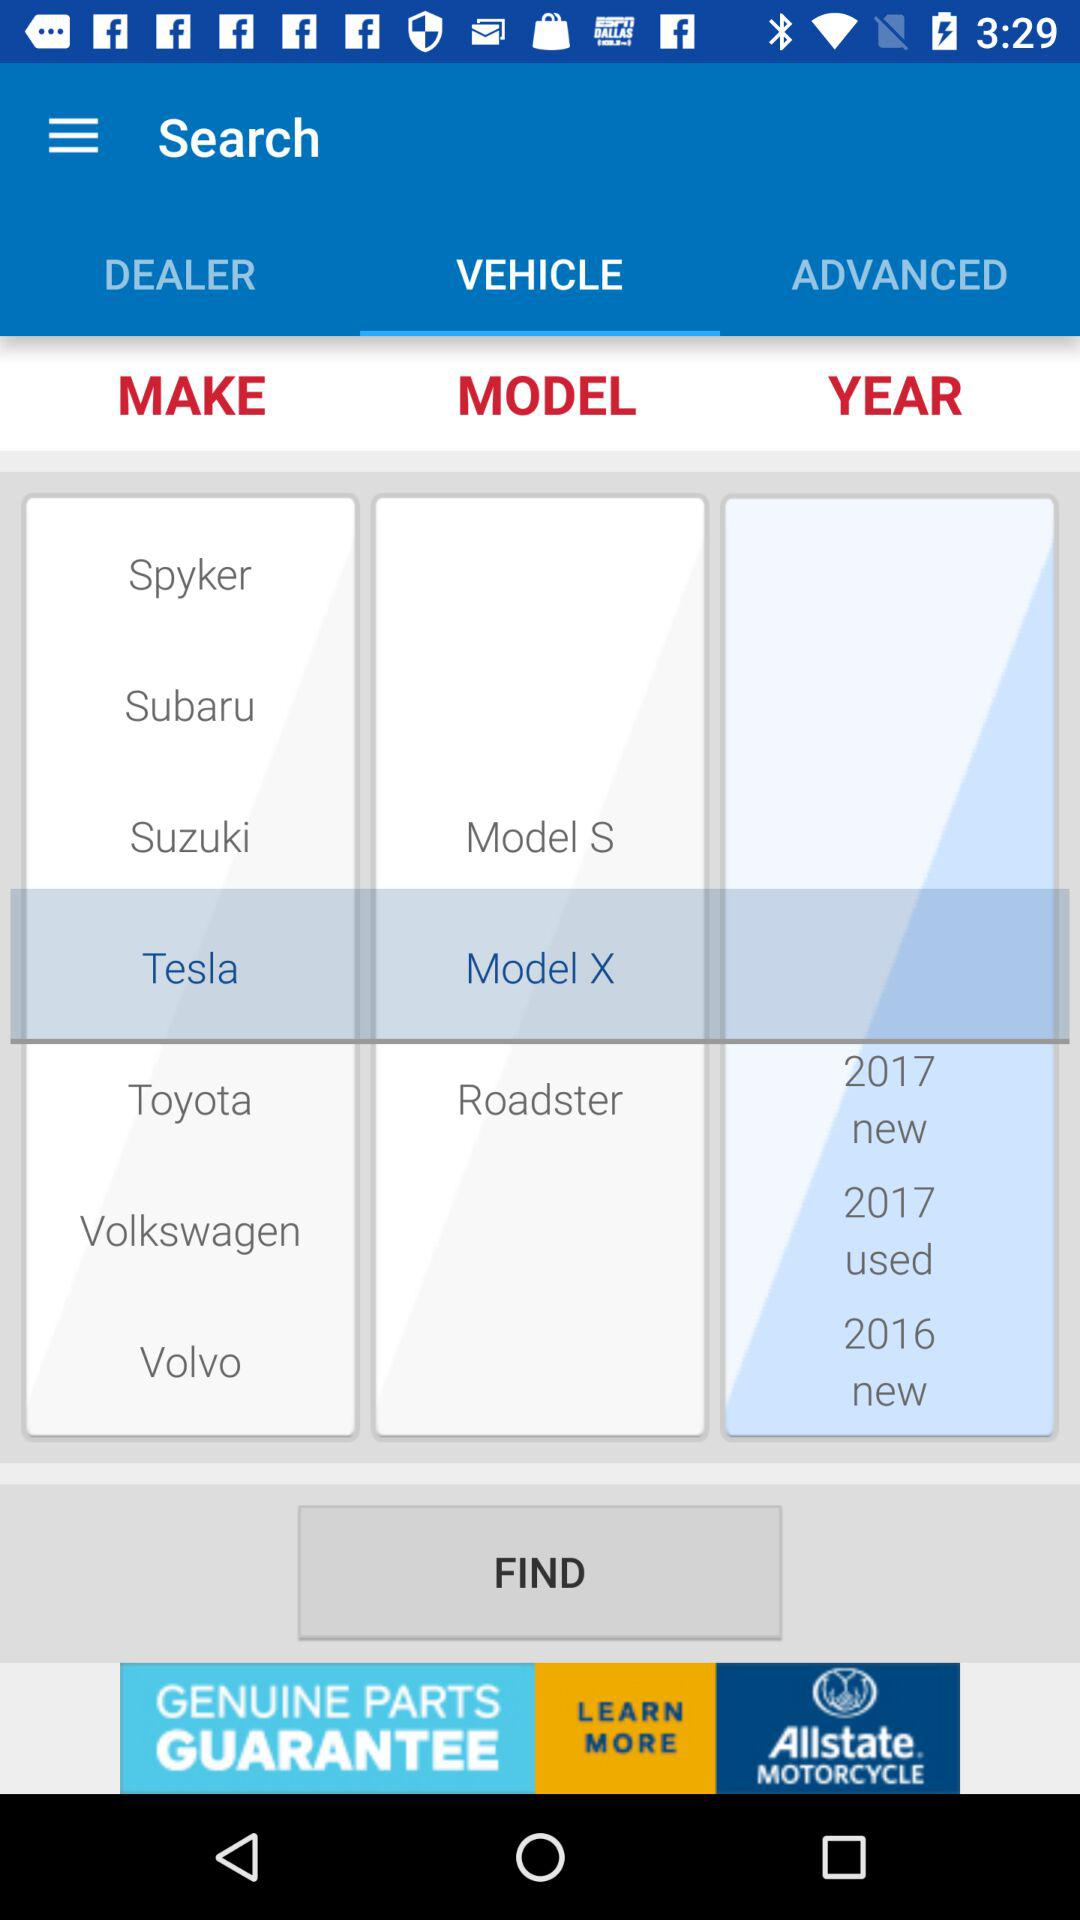How many years are available to select from?
Answer the question using a single word or phrase. 3 